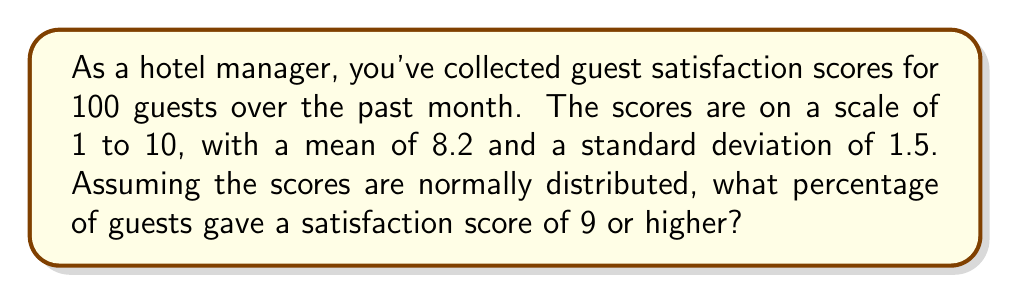Can you answer this question? To solve this problem, we need to use the properties of the normal distribution and the concept of z-scores.

Step 1: Calculate the z-score for a satisfaction score of 9.
z-score formula: $z = \frac{x - \mu}{\sigma}$
Where $x$ is the value we're interested in, $\mu$ is the mean, and $\sigma$ is the standard deviation.

$z = \frac{9 - 8.2}{1.5} = \frac{0.8}{1.5} \approx 0.5333$

Step 2: Use a standard normal distribution table or calculator to find the area to the left of the z-score.
Area to the left of z = 0.5333 is approximately 0.7032.

Step 3: Calculate the area to the right of the z-score (which represents the percentage of guests who gave a score of 9 or higher).
Area to the right = 1 - 0.7032 = 0.2968

Step 4: Convert to a percentage.
0.2968 * 100 = 29.68%

Therefore, approximately 29.68% of guests gave a satisfaction score of 9 or higher.
Answer: 29.68% 